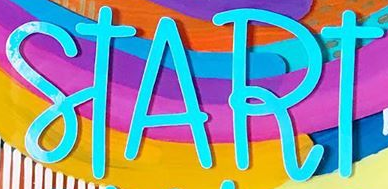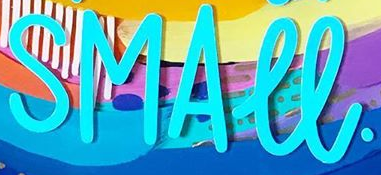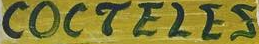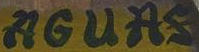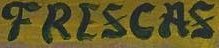Identify the words shown in these images in order, separated by a semicolon. START; SMALL.; COCTELES; AGUAS; FRESCAS 